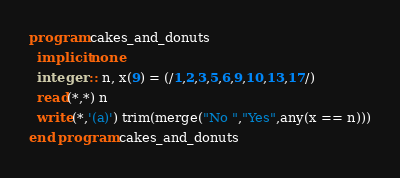<code> <loc_0><loc_0><loc_500><loc_500><_FORTRAN_>program cakes_and_donuts
  implicit none
  integer :: n, x(9) = (/1,2,3,5,6,9,10,13,17/)
  read(*,*) n
  write(*,'(a)') trim(merge("No ","Yes",any(x == n)))
end program cakes_and_donuts</code> 